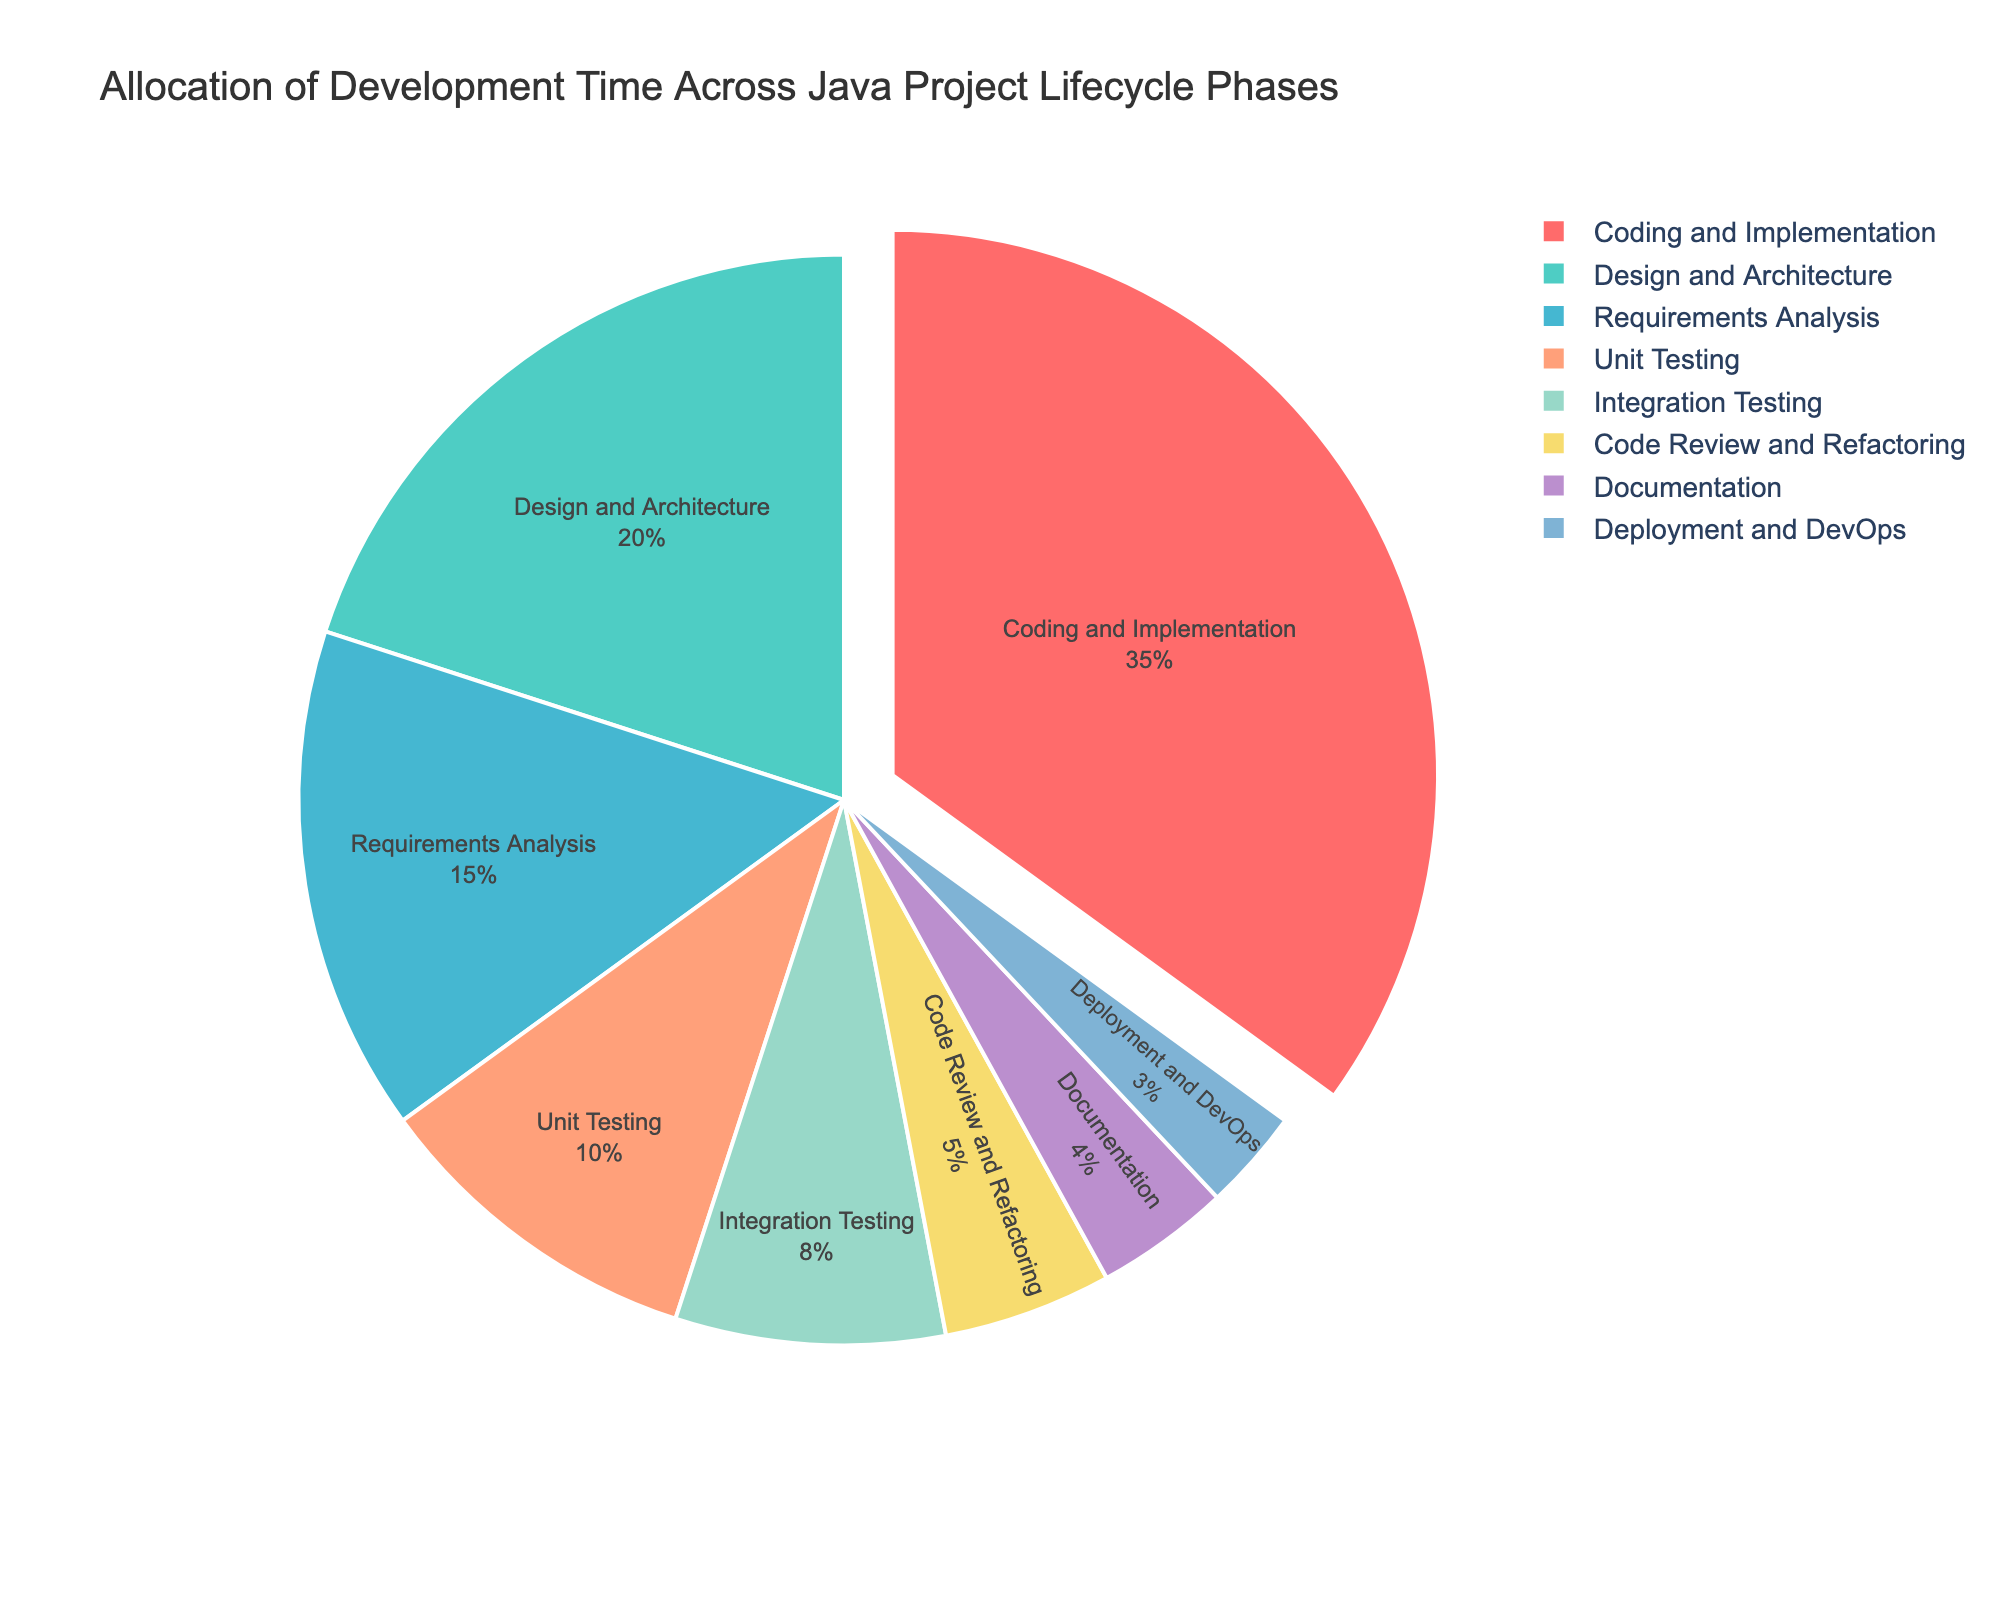What is the largest phase in terms of time allocation? Identify the phase with the highest percentage by looking at the segments of the pie chart. The largest segment, marked as "Coding and Implementation," occupies 35%.
Answer: Coding and Implementation How much more time is spent on "Coding and Implementation" compared to "Unit Testing"? Subtract the percentage of "Unit Testing" (10%) from "Coding and Implementation" (35%) to find the difference.
Answer: 25% Which phase takes up more time, "Design and Architecture" or "Requirements Analysis"? Compare the percentages of "Design and Architecture" (20%) and "Requirements Analysis" (15%).
Answer: Design and Architecture What is the total percentage of time spent on all testing phases combined? Sum the percentages of "Unit Testing" (10%) and "Integration Testing" (8%).
Answer: 18% Which phase has the smallest time allocation? Identify the phase with the smallest percentage by looking at the segments of the pie chart. The smallest segment is "Deployment and DevOps," which occupies 3%.
Answer: Deployment and DevOps If you combine "Documentation" and "Code Review and Refactoring," what percentage of the total time do they represent? Add the percentages for "Documentation" (4%) and "Code Review and Refactoring" (5%).
Answer: 9% How does the time allocated to "Coding and Implementation" compare with the sum of "Design and Architecture" and "Requirements Analysis"? Sum the percentages for "Design and Architecture" (20%) and "Requirements Analysis" (15%) to get 35%. Since "Coding and Implementation" is also 35%, they are equal.
Answer: Equal What is the percentage difference between "Integration Testing" and "Deployment and DevOps"? Subtract "Deployment and DevOps" (3%) from "Integration Testing" (8%) to find the difference.
Answer: 5% Rank the phases that have more than 10% time allocation. Identify and rank the phases with percentages greater than 10% in descending order: "Coding and Implementation" (35%), "Design and Architecture" (20%), "Requirements Analysis" (15%).
Answer: Coding and Implementation, Design and Architecture, Requirements Analysis What percentage of the time is allocated to activities other than "Coding and Implementation"? Subtract the percentage for "Coding and Implementation" (35%) from 100% to find the total percentage for all other phases.
Answer: 65% 